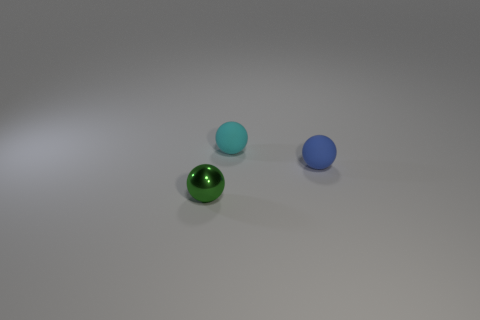Subtract all small cyan rubber spheres. How many spheres are left? 2 Add 2 tiny spheres. How many objects exist? 5 Subtract all cyan spheres. How many spheres are left? 2 Subtract all small purple metal cubes. Subtract all blue rubber objects. How many objects are left? 2 Add 1 cyan rubber things. How many cyan rubber things are left? 2 Add 1 small cyan balls. How many small cyan balls exist? 2 Subtract 0 cyan cylinders. How many objects are left? 3 Subtract 3 spheres. How many spheres are left? 0 Subtract all yellow spheres. Subtract all cyan blocks. How many spheres are left? 3 Subtract all green cylinders. How many red balls are left? 0 